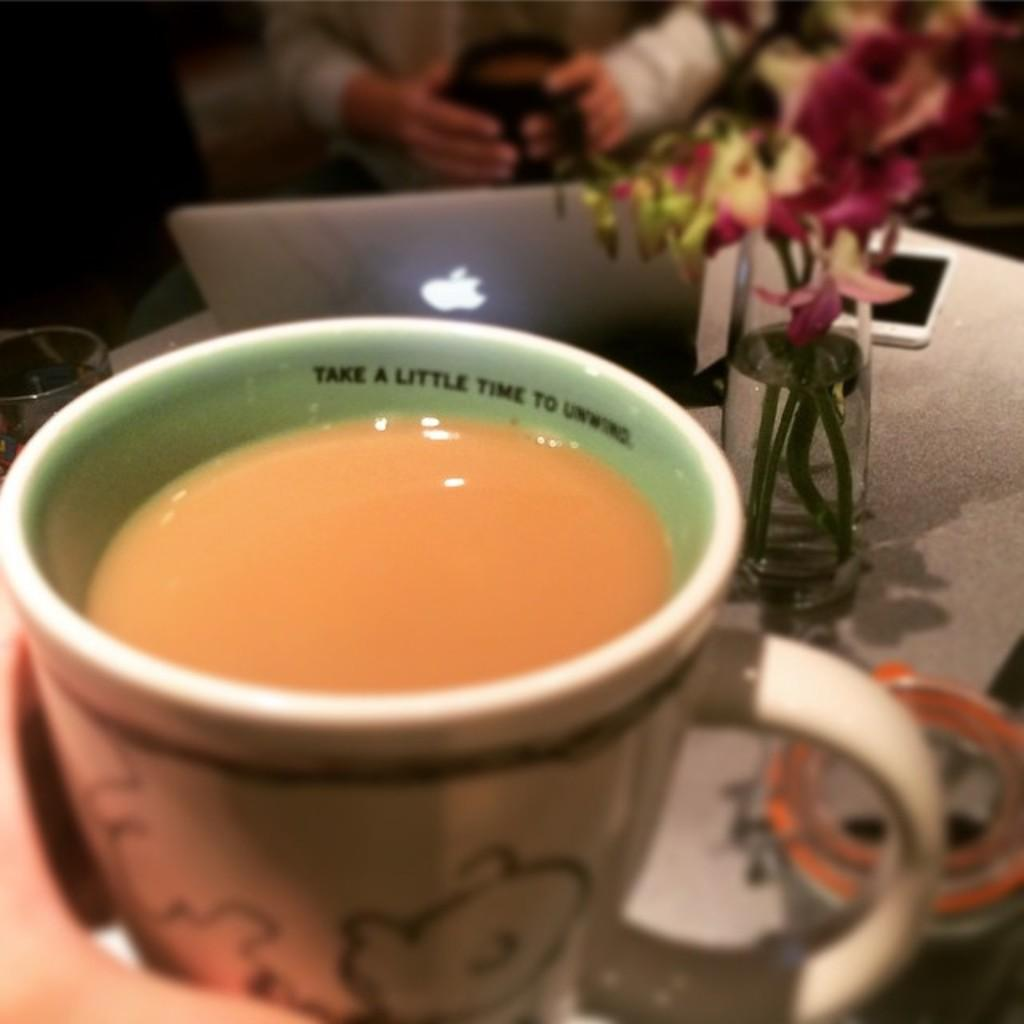What is the main object in the center of the image? There is a table in the center of the image. What items can be seen on the table? There is a glass, a flower pot, a laptop, a mobile, and a coffee cup on the table. What is the person in the image doing? The person is at the top of the image, but their actions are not specified. What type of thrill can be seen on the person's face in the image? There is no indication of a thrill or any specific emotion on the person's face in the image. What type of meal is being prepared on the table in the image? There is no meal preparation visible in the image; the table contains a glass, a flower pot, a laptop, a mobile, and a coffee cup. 